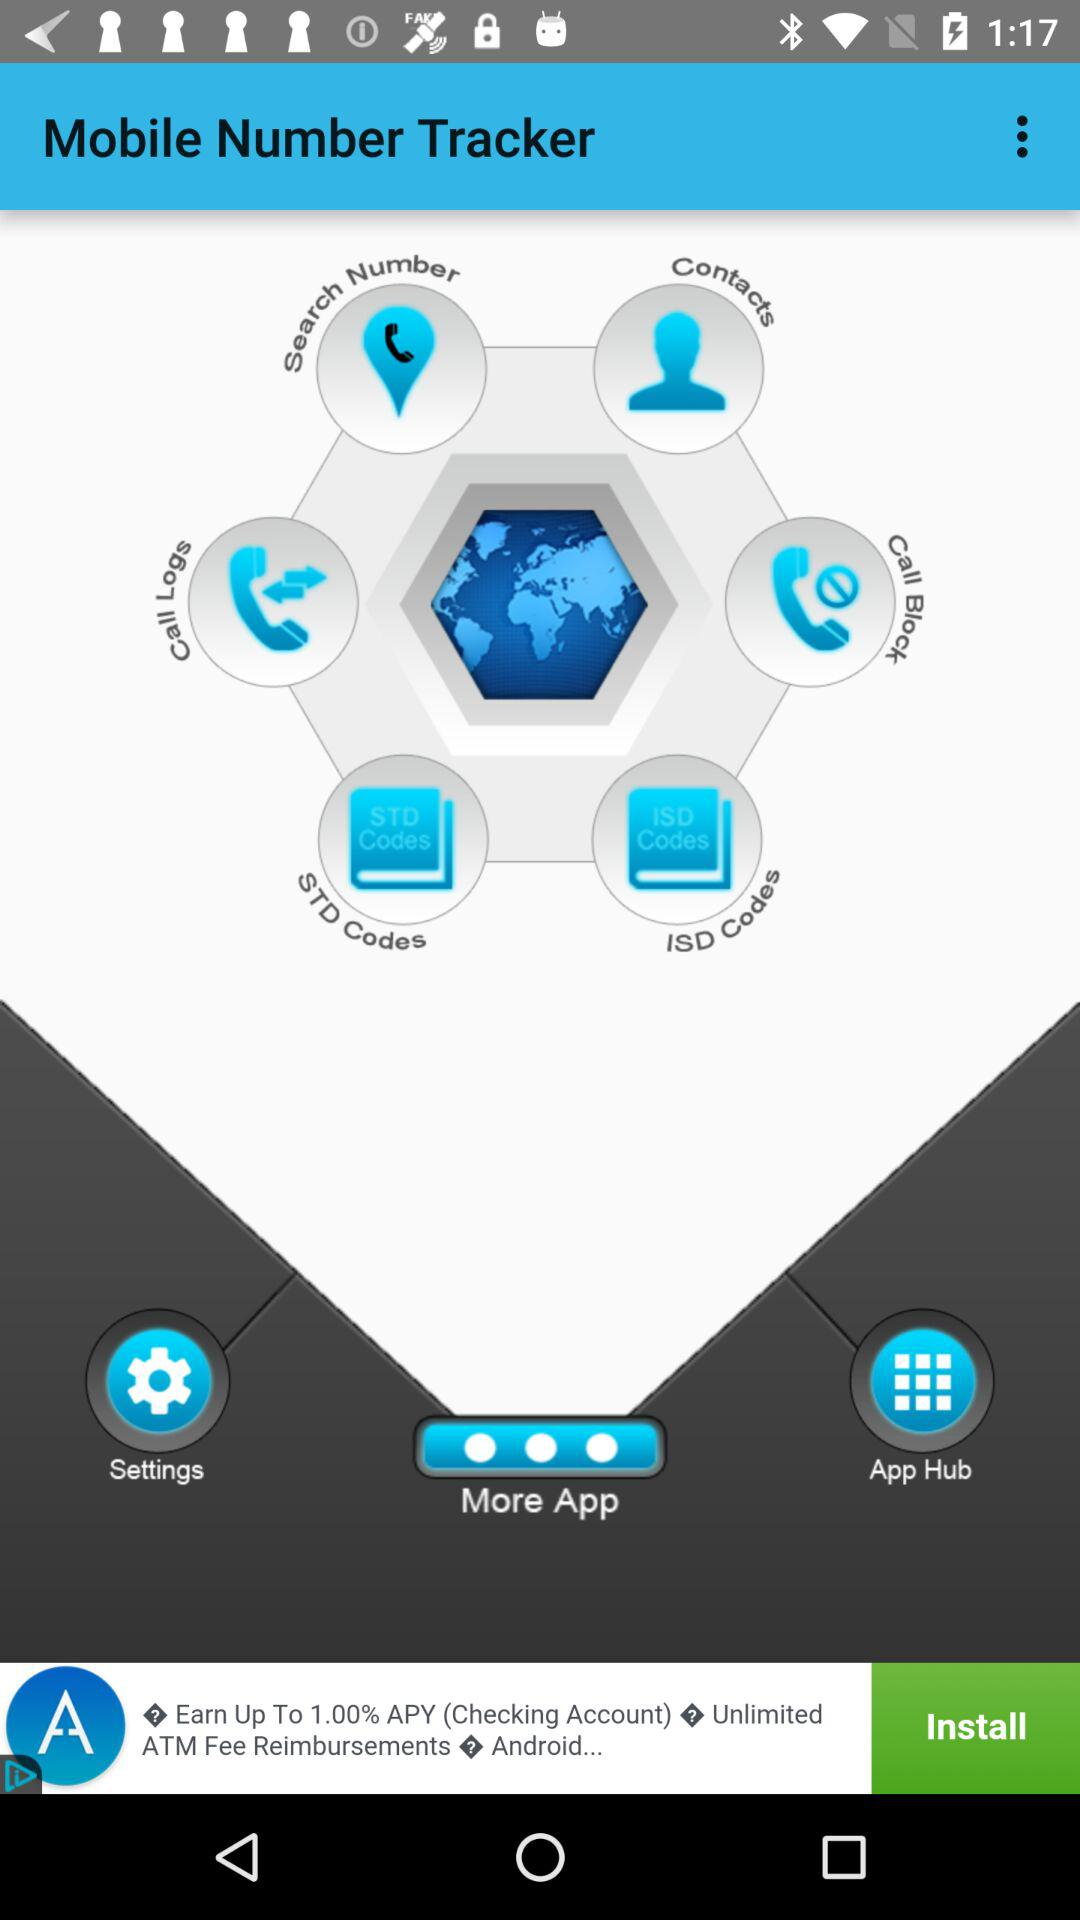What is the application name? The application name is "Mobile Number Tracker". 